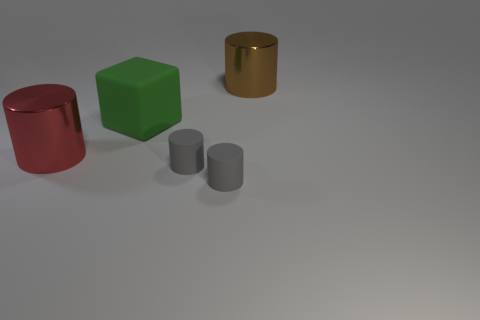Add 1 gray matte cylinders. How many objects exist? 6 Subtract all red cylinders. How many cylinders are left? 3 Subtract all brown cylinders. Subtract all gray blocks. How many cylinders are left? 3 Subtract all blocks. How many objects are left? 4 Subtract 1 green blocks. How many objects are left? 4 Subtract all big green matte cubes. Subtract all small objects. How many objects are left? 2 Add 2 brown cylinders. How many brown cylinders are left? 3 Add 5 small red shiny things. How many small red shiny things exist? 5 